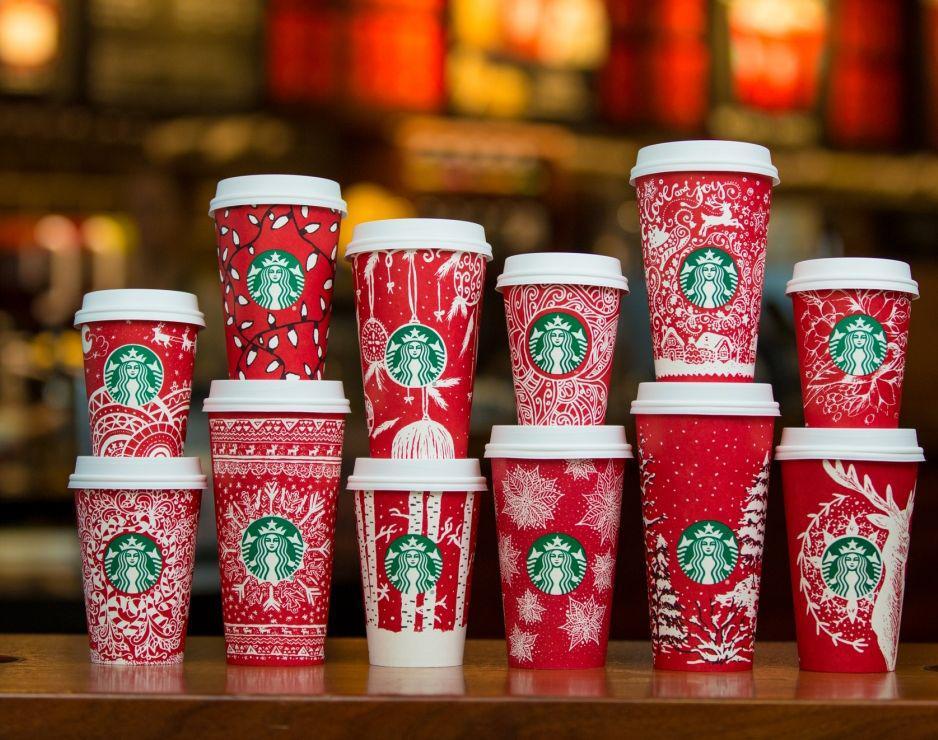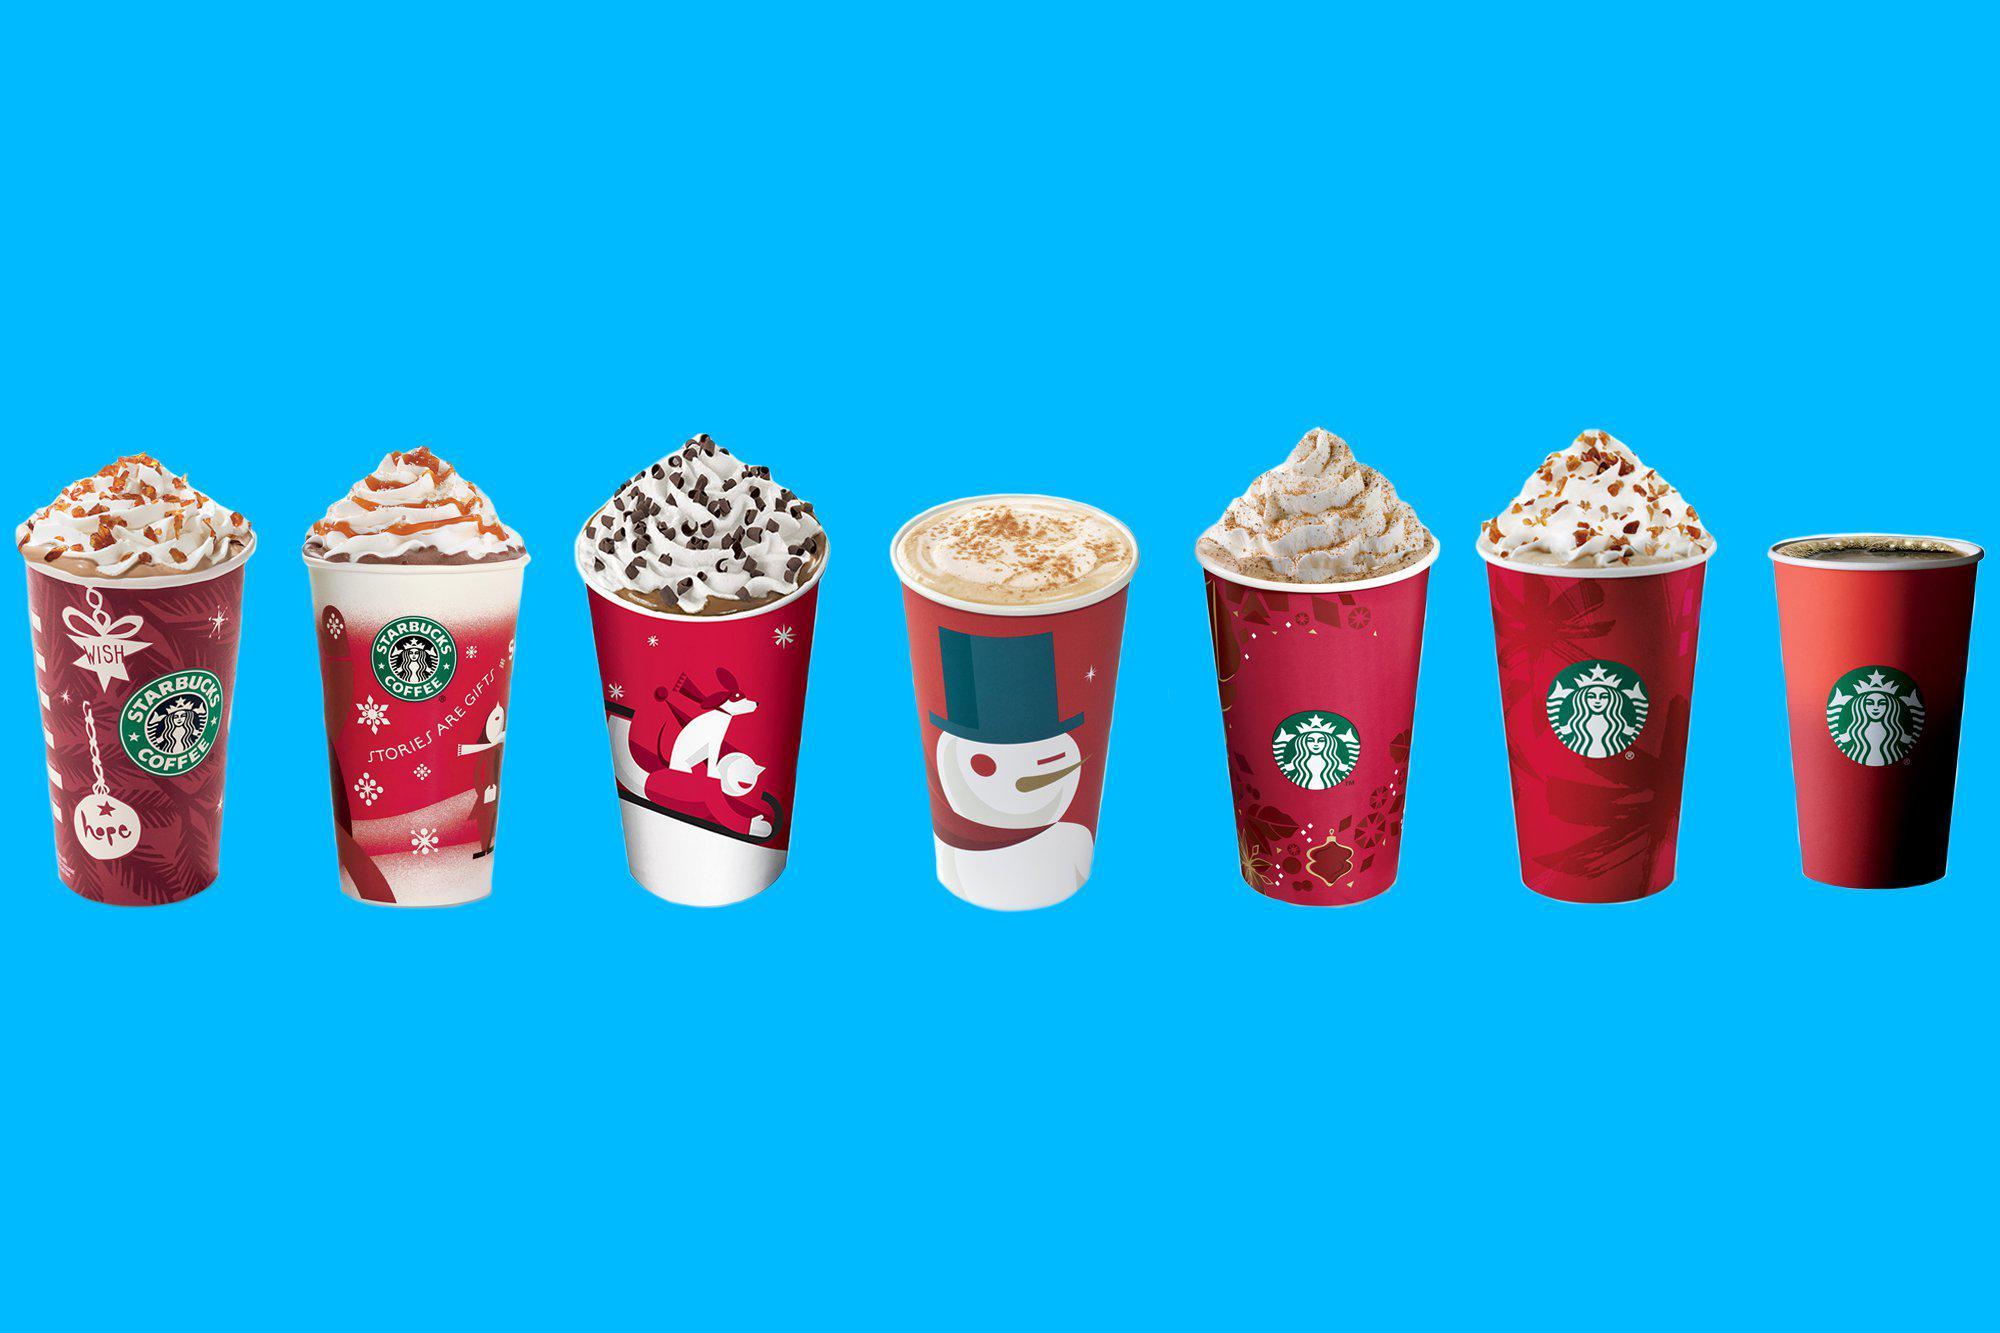The first image is the image on the left, the second image is the image on the right. Given the left and right images, does the statement "In at least one image there are seven red starbucks christmas cups full of coffee." hold true? Answer yes or no. Yes. 